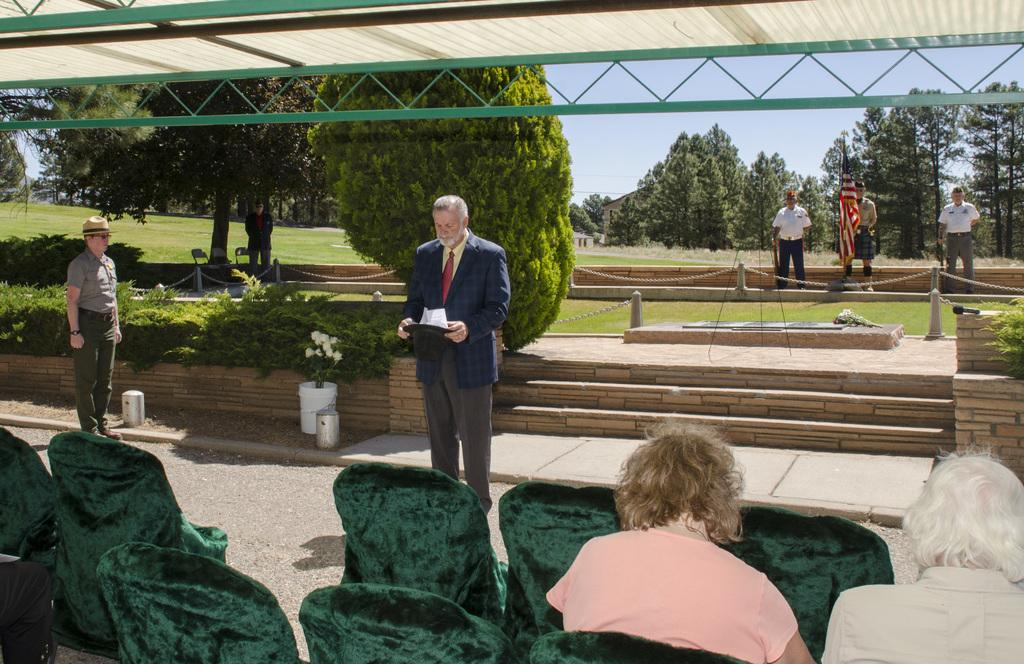What objects are in the foreground of the image? There are chairs in the foreground of the image. What are the people in the chairs doing? People are sitting in the chairs. What can be seen in the background of the image? There are trees, grassland, people, a flag, and the sky visible in the background of the image. What type of canvas is being used by the person wearing the crown in the image? There is no canvas or person wearing a crown present in the image. 